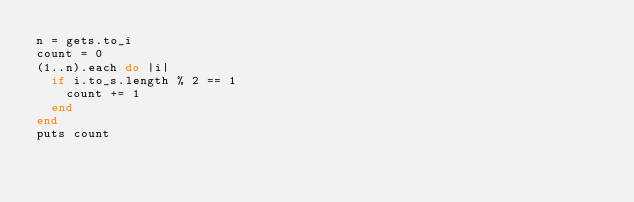Convert code to text. <code><loc_0><loc_0><loc_500><loc_500><_Ruby_>n = gets.to_i
count = 0
(1..n).each do |i|
  if i.to_s.length % 2 == 1
    count += 1
  end
end
puts count</code> 